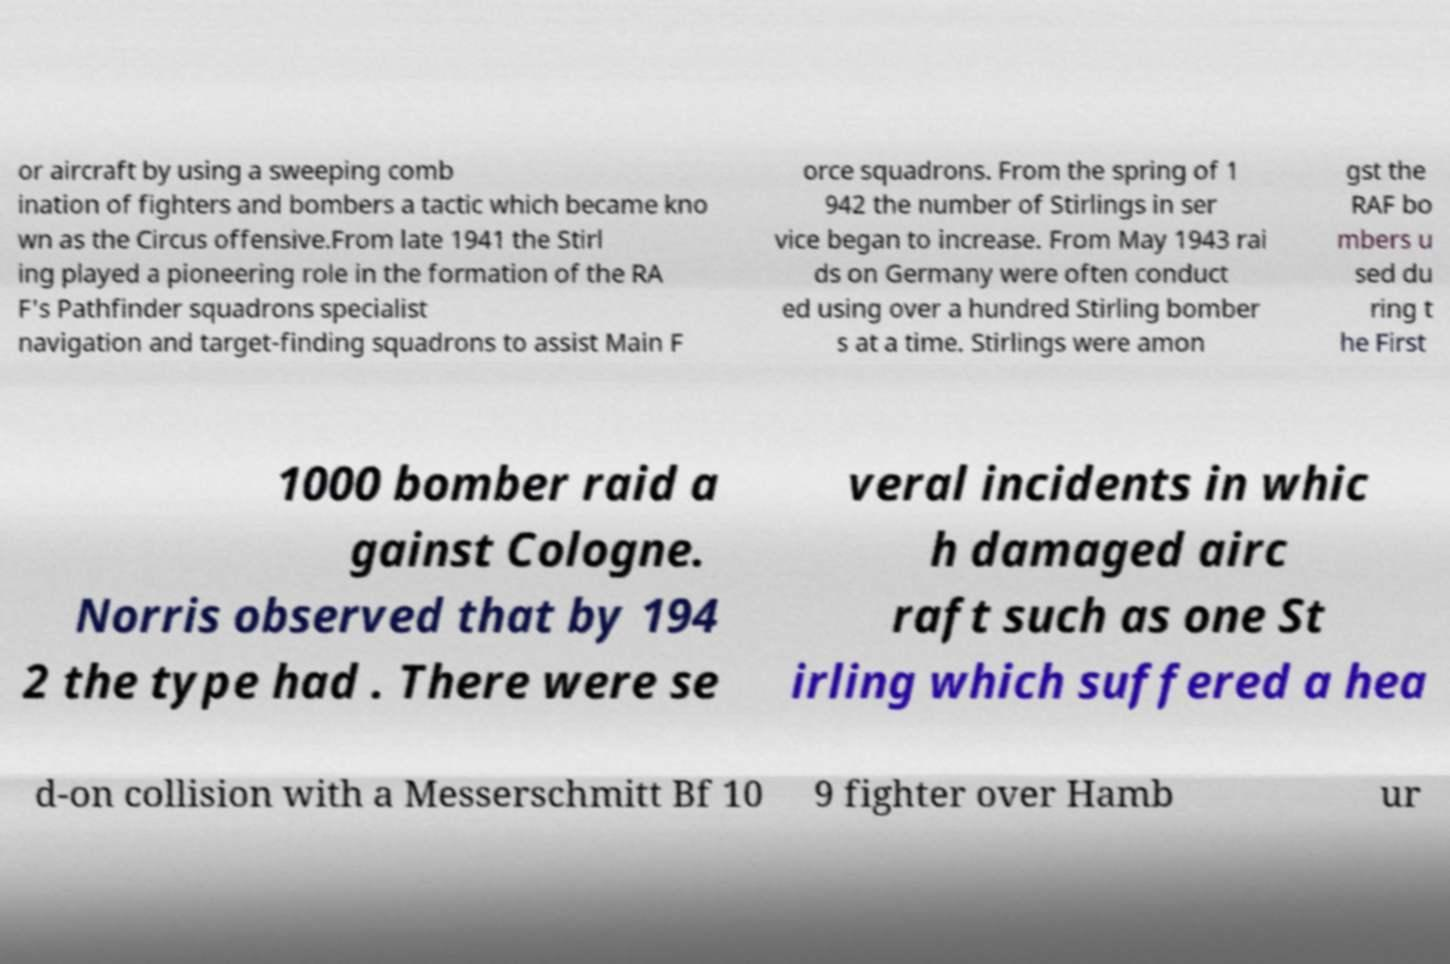Can you read and provide the text displayed in the image?This photo seems to have some interesting text. Can you extract and type it out for me? or aircraft by using a sweeping comb ination of fighters and bombers a tactic which became kno wn as the Circus offensive.From late 1941 the Stirl ing played a pioneering role in the formation of the RA F's Pathfinder squadrons specialist navigation and target-finding squadrons to assist Main F orce squadrons. From the spring of 1 942 the number of Stirlings in ser vice began to increase. From May 1943 rai ds on Germany were often conduct ed using over a hundred Stirling bomber s at a time. Stirlings were amon gst the RAF bo mbers u sed du ring t he First 1000 bomber raid a gainst Cologne. Norris observed that by 194 2 the type had . There were se veral incidents in whic h damaged airc raft such as one St irling which suffered a hea d-on collision with a Messerschmitt Bf 10 9 fighter over Hamb ur 